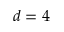<formula> <loc_0><loc_0><loc_500><loc_500>d = 4</formula> 